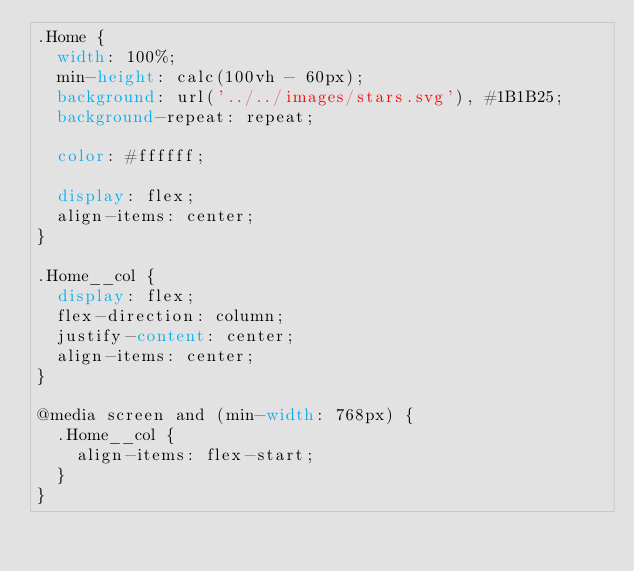<code> <loc_0><loc_0><loc_500><loc_500><_CSS_>.Home {
  width: 100%;
  min-height: calc(100vh - 60px);
  background: url('../../images/stars.svg'), #1B1B25;
  background-repeat: repeat;

  color: #ffffff;

  display: flex;
  align-items: center;
}

.Home__col {
  display: flex;
  flex-direction: column;
  justify-content: center;
  align-items: center;
}

@media screen and (min-width: 768px) {
  .Home__col {
    align-items: flex-start;
  }
}
</code> 